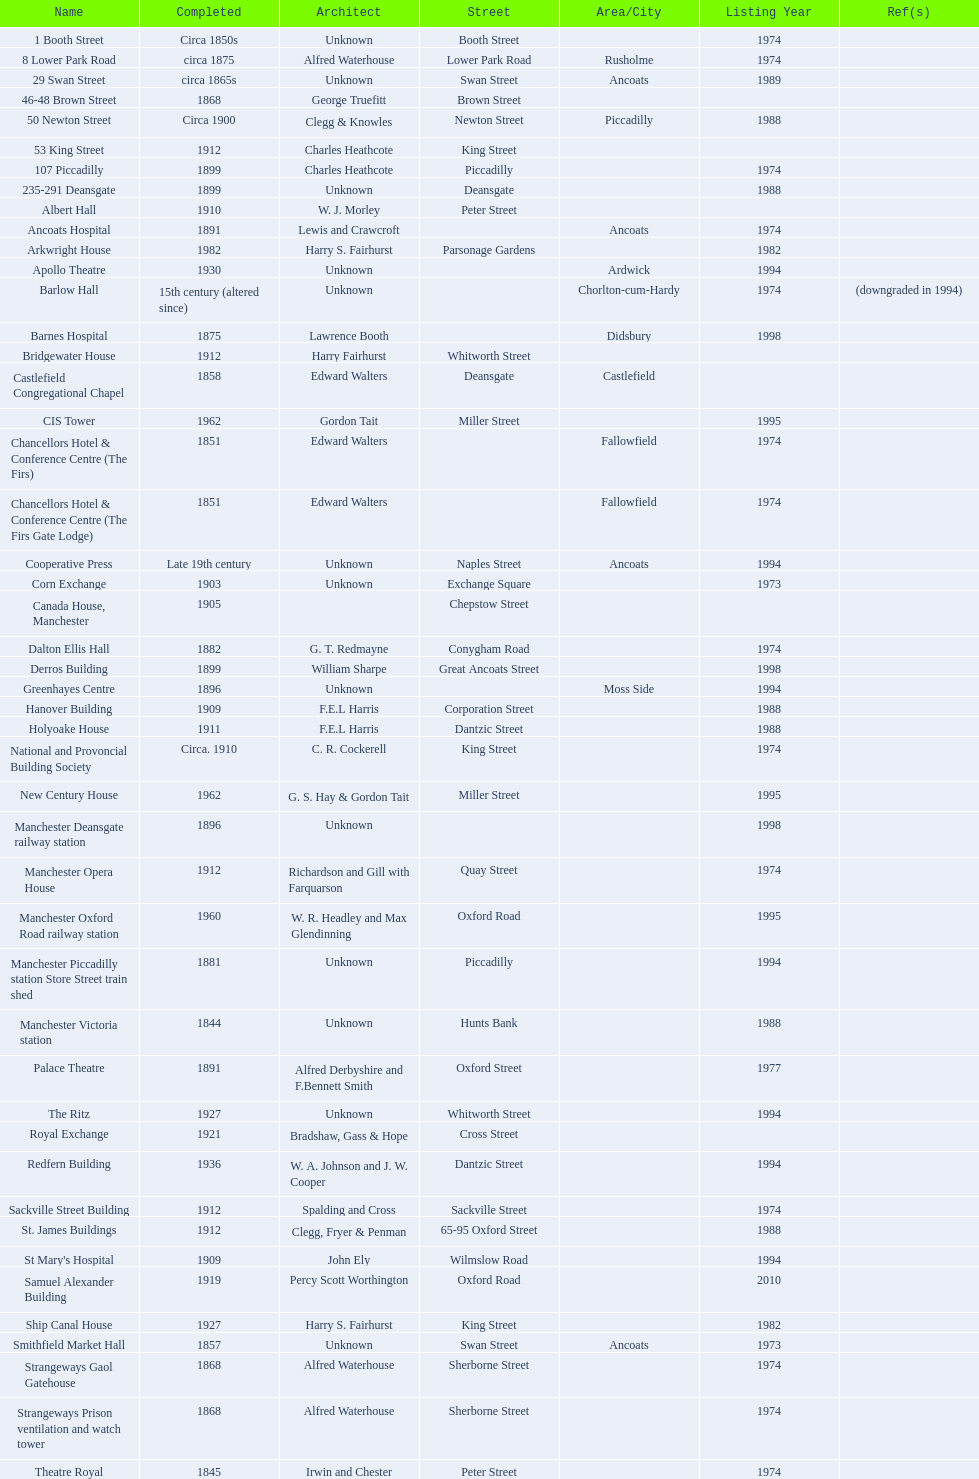Which year has the most buildings listed? 1974. 